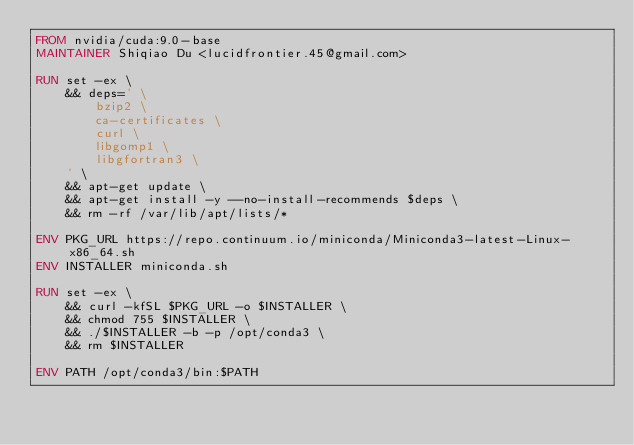<code> <loc_0><loc_0><loc_500><loc_500><_Dockerfile_>FROM nvidia/cuda:9.0-base
MAINTAINER Shiqiao Du <lucidfrontier.45@gmail.com>

RUN set -ex \
    && deps=' \
        bzip2 \
        ca-certificates \
        curl \
        libgomp1 \
        libgfortran3 \
    ' \
    && apt-get update \
    && apt-get install -y --no-install-recommends $deps \
    && rm -rf /var/lib/apt/lists/*

ENV PKG_URL https://repo.continuum.io/miniconda/Miniconda3-latest-Linux-x86_64.sh
ENV INSTALLER miniconda.sh

RUN set -ex \
    && curl -kfSL $PKG_URL -o $INSTALLER \
    && chmod 755 $INSTALLER \
    && ./$INSTALLER -b -p /opt/conda3 \
    && rm $INSTALLER

ENV PATH /opt/conda3/bin:$PATH
</code> 